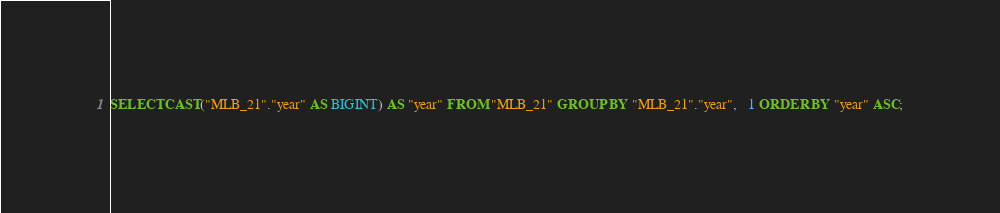<code> <loc_0><loc_0><loc_500><loc_500><_SQL_>SELECT CAST("MLB_21"."year" AS BIGINT) AS "year" FROM "MLB_21" GROUP BY "MLB_21"."year",   1 ORDER BY "year" ASC;
</code> 